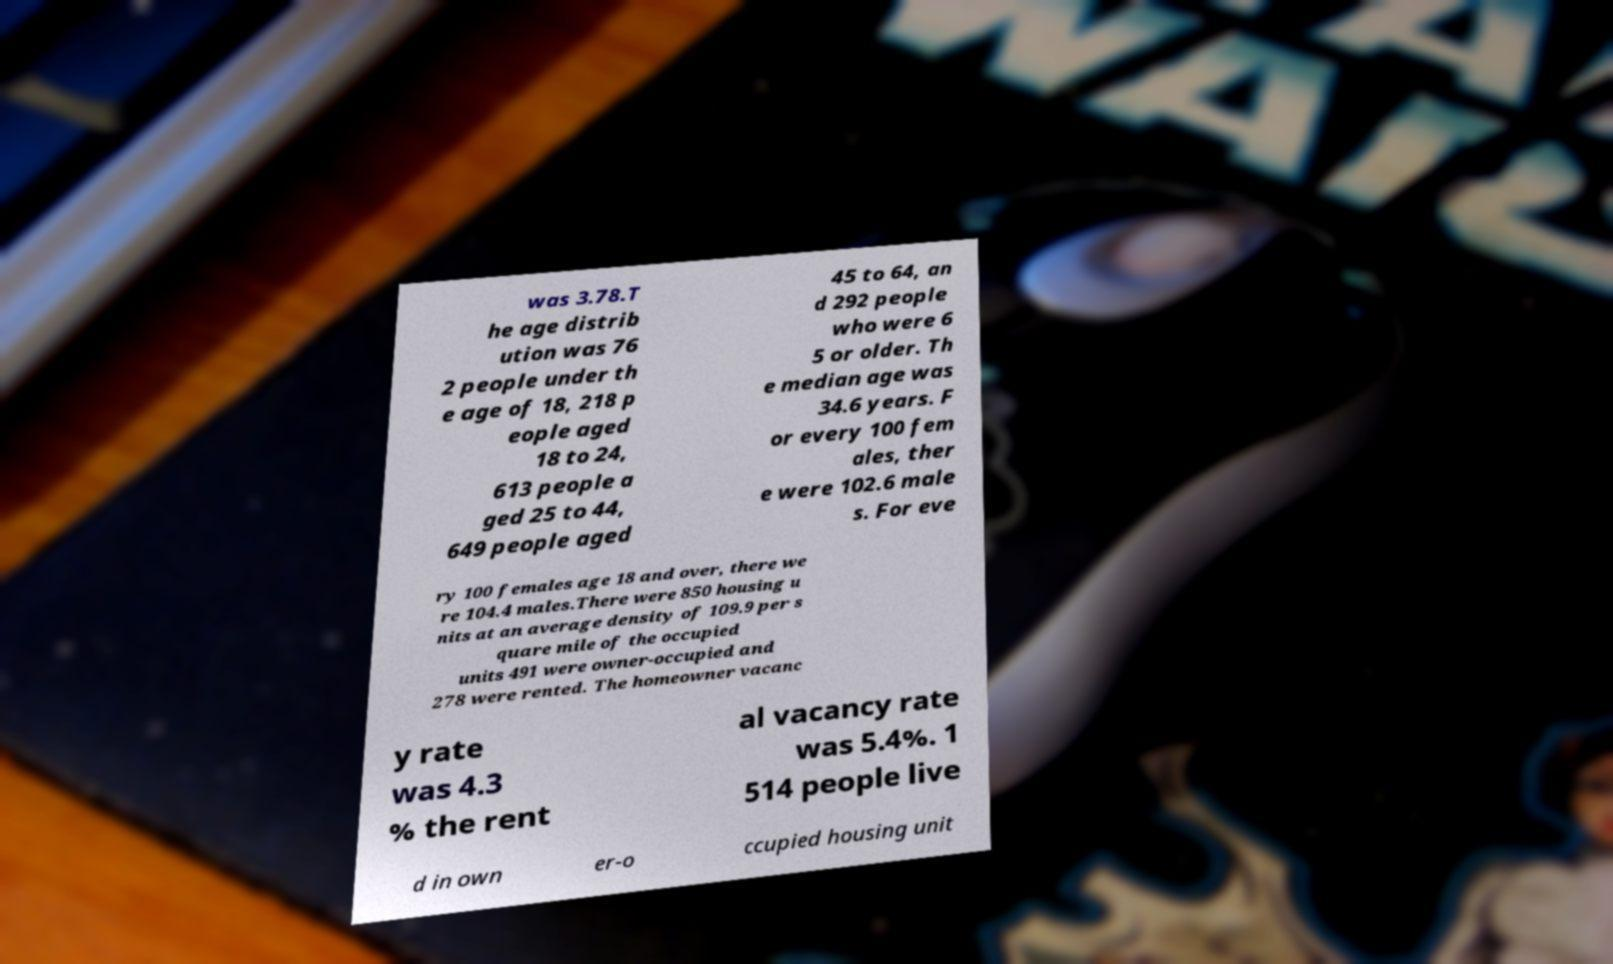Could you extract and type out the text from this image? was 3.78.T he age distrib ution was 76 2 people under th e age of 18, 218 p eople aged 18 to 24, 613 people a ged 25 to 44, 649 people aged 45 to 64, an d 292 people who were 6 5 or older. Th e median age was 34.6 years. F or every 100 fem ales, ther e were 102.6 male s. For eve ry 100 females age 18 and over, there we re 104.4 males.There were 850 housing u nits at an average density of 109.9 per s quare mile of the occupied units 491 were owner-occupied and 278 were rented. The homeowner vacanc y rate was 4.3 % the rent al vacancy rate was 5.4%. 1 514 people live d in own er-o ccupied housing unit 